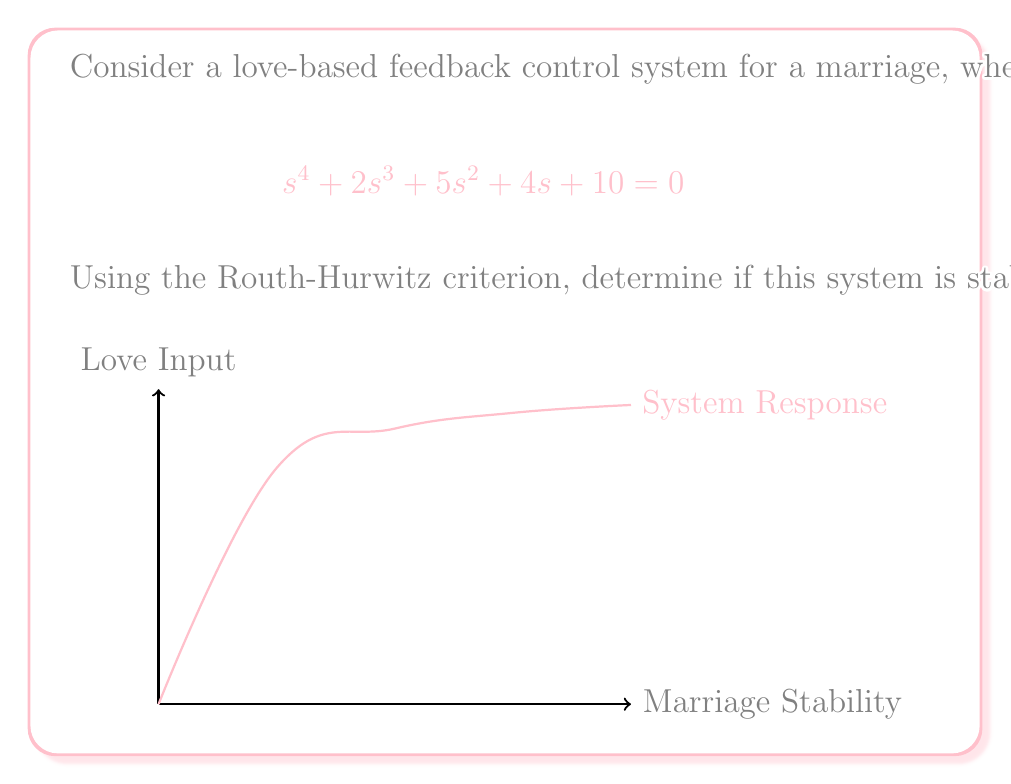What is the answer to this math problem? To determine the stability of the system using the Routh-Hurwitz criterion, we follow these steps:

1. Construct the Routh array:
   $$\begin{array}{c|cccc}
   s^4 & 1 & 5 & 10 \\
   s^3 & 2 & 4 & 0 \\
   s^2 & b_1 & b_2 & \\
   s^1 & c_1 & \\
   s^0 & d_1 &
   \end{array}$$

2. Calculate $b_1$:
   $$b_1 = \frac{(2)(5) - (1)(4)}{2} = \frac{10 - 4}{2} = 3$$

3. Calculate $b_2$:
   $$b_2 = \frac{(2)(10) - (1)(0)}{2} = \frac{20}{2} = 10$$

4. Calculate $c_1$:
   $$c_1 = \frac{(3)(4) - (2)(10)}{3} = \frac{12 - 20}{3} = -\frac{8}{3}$$

5. Calculate $d_1$:
   $$d_1 = \frac{(-\frac{8}{3})(10) - (3)(0)}{-\frac{8}{3}} = 10$$

6. The complete Routh array:
   $$\begin{array}{c|cccc}
   s^4 & 1 & 5 & 10 \\
   s^3 & 2 & 4 & 0 \\
   s^2 & 3 & 10 & \\
   s^1 & -\frac{8}{3} & \\
   s^0 & 10 &
   \end{array}$$

7. Analyze the first column of the Routh array:
   There is a sign change in the first column (between $3$ and $-\frac{8}{3}$).

According to the Routh-Hurwitz criterion, the number of sign changes in the first column of the Routh array indicates the number of roots with positive real parts. Since there is one sign change, the system has one root with a positive real part.
Answer: The system is unstable. 